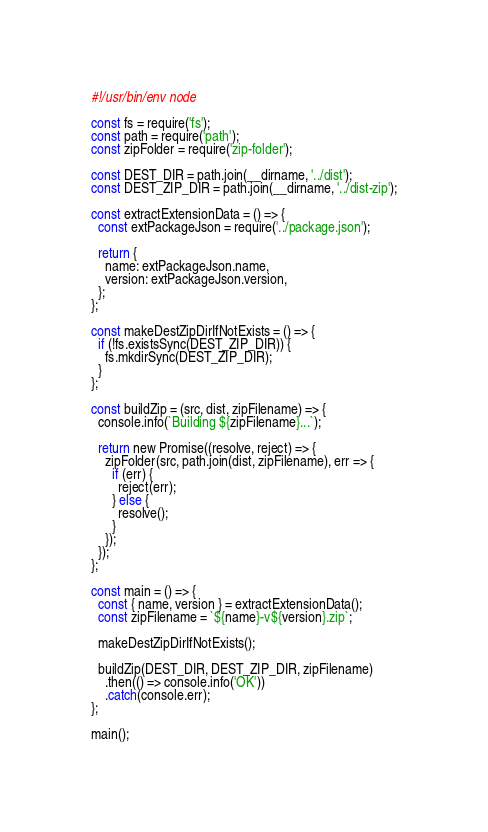Convert code to text. <code><loc_0><loc_0><loc_500><loc_500><_JavaScript_>#!/usr/bin/env node

const fs = require('fs');
const path = require('path');
const zipFolder = require('zip-folder');

const DEST_DIR = path.join(__dirname, '../dist');
const DEST_ZIP_DIR = path.join(__dirname, '../dist-zip');

const extractExtensionData = () => {
  const extPackageJson = require('../package.json');

  return {
    name: extPackageJson.name,
    version: extPackageJson.version,
  };
};

const makeDestZipDirIfNotExists = () => {
  if (!fs.existsSync(DEST_ZIP_DIR)) {
    fs.mkdirSync(DEST_ZIP_DIR);
  }
};

const buildZip = (src, dist, zipFilename) => {
  console.info(`Building ${zipFilename}...`);

  return new Promise((resolve, reject) => {
    zipFolder(src, path.join(dist, zipFilename), err => {
      if (err) {
        reject(err);
      } else {
        resolve();
      }
    });
  });
};

const main = () => {
  const { name, version } = extractExtensionData();
  const zipFilename = `${name}-v${version}.zip`;

  makeDestZipDirIfNotExists();

  buildZip(DEST_DIR, DEST_ZIP_DIR, zipFilename)
    .then(() => console.info('OK'))
    .catch(console.err);
};

main();
</code> 